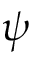Convert formula to latex. <formula><loc_0><loc_0><loc_500><loc_500>\psi</formula> 